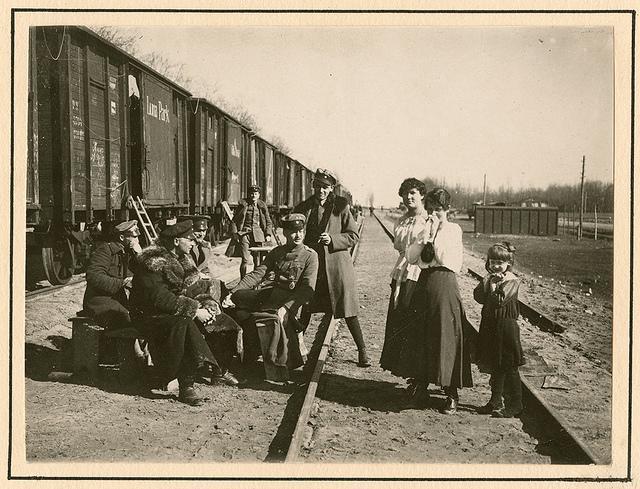How many females are there?
Give a very brief answer. 3. How many people can you see?
Give a very brief answer. 7. 